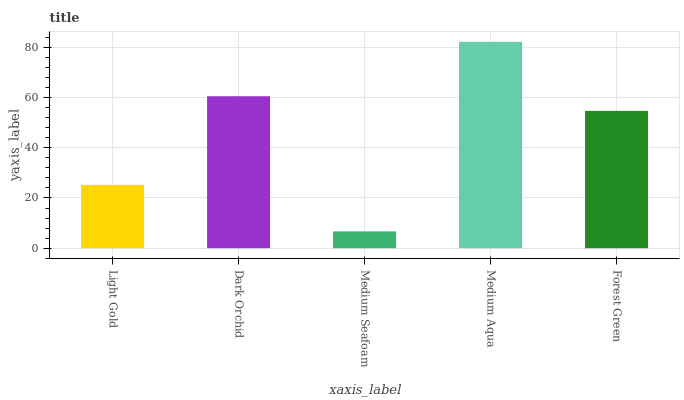Is Medium Seafoam the minimum?
Answer yes or no. Yes. Is Medium Aqua the maximum?
Answer yes or no. Yes. Is Dark Orchid the minimum?
Answer yes or no. No. Is Dark Orchid the maximum?
Answer yes or no. No. Is Dark Orchid greater than Light Gold?
Answer yes or no. Yes. Is Light Gold less than Dark Orchid?
Answer yes or no. Yes. Is Light Gold greater than Dark Orchid?
Answer yes or no. No. Is Dark Orchid less than Light Gold?
Answer yes or no. No. Is Forest Green the high median?
Answer yes or no. Yes. Is Forest Green the low median?
Answer yes or no. Yes. Is Medium Aqua the high median?
Answer yes or no. No. Is Light Gold the low median?
Answer yes or no. No. 